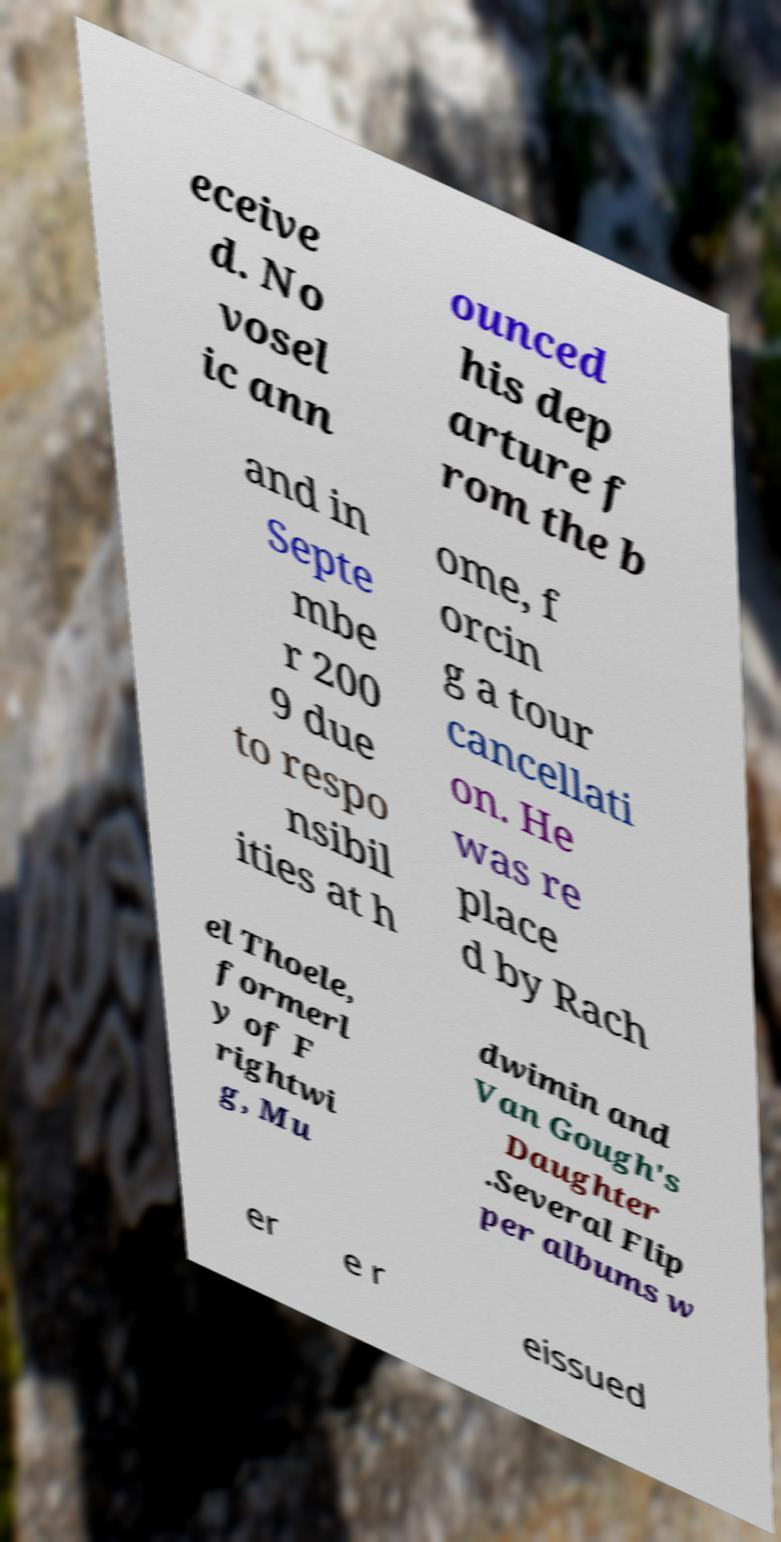Please identify and transcribe the text found in this image. eceive d. No vosel ic ann ounced his dep arture f rom the b and in Septe mbe r 200 9 due to respo nsibil ities at h ome, f orcin g a tour cancellati on. He was re place d by Rach el Thoele, formerl y of F rightwi g, Mu dwimin and Van Gough's Daughter .Several Flip per albums w er e r eissued 